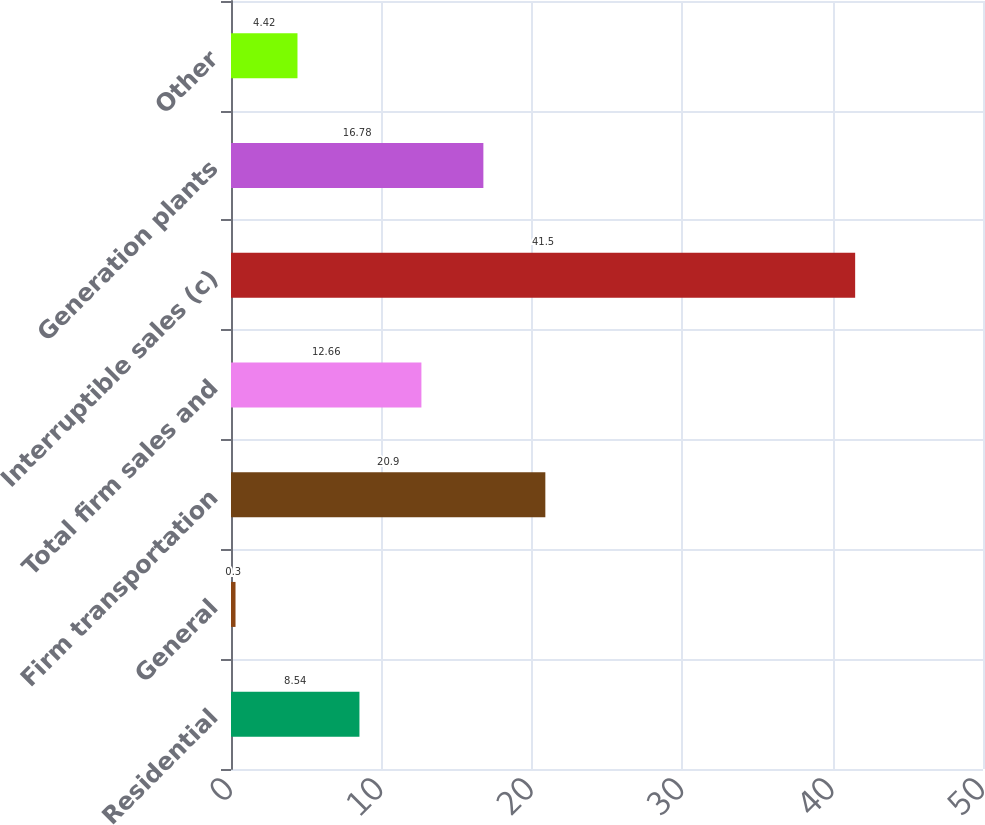<chart> <loc_0><loc_0><loc_500><loc_500><bar_chart><fcel>Residential<fcel>General<fcel>Firm transportation<fcel>Total firm sales and<fcel>Interruptible sales (c)<fcel>Generation plants<fcel>Other<nl><fcel>8.54<fcel>0.3<fcel>20.9<fcel>12.66<fcel>41.5<fcel>16.78<fcel>4.42<nl></chart> 